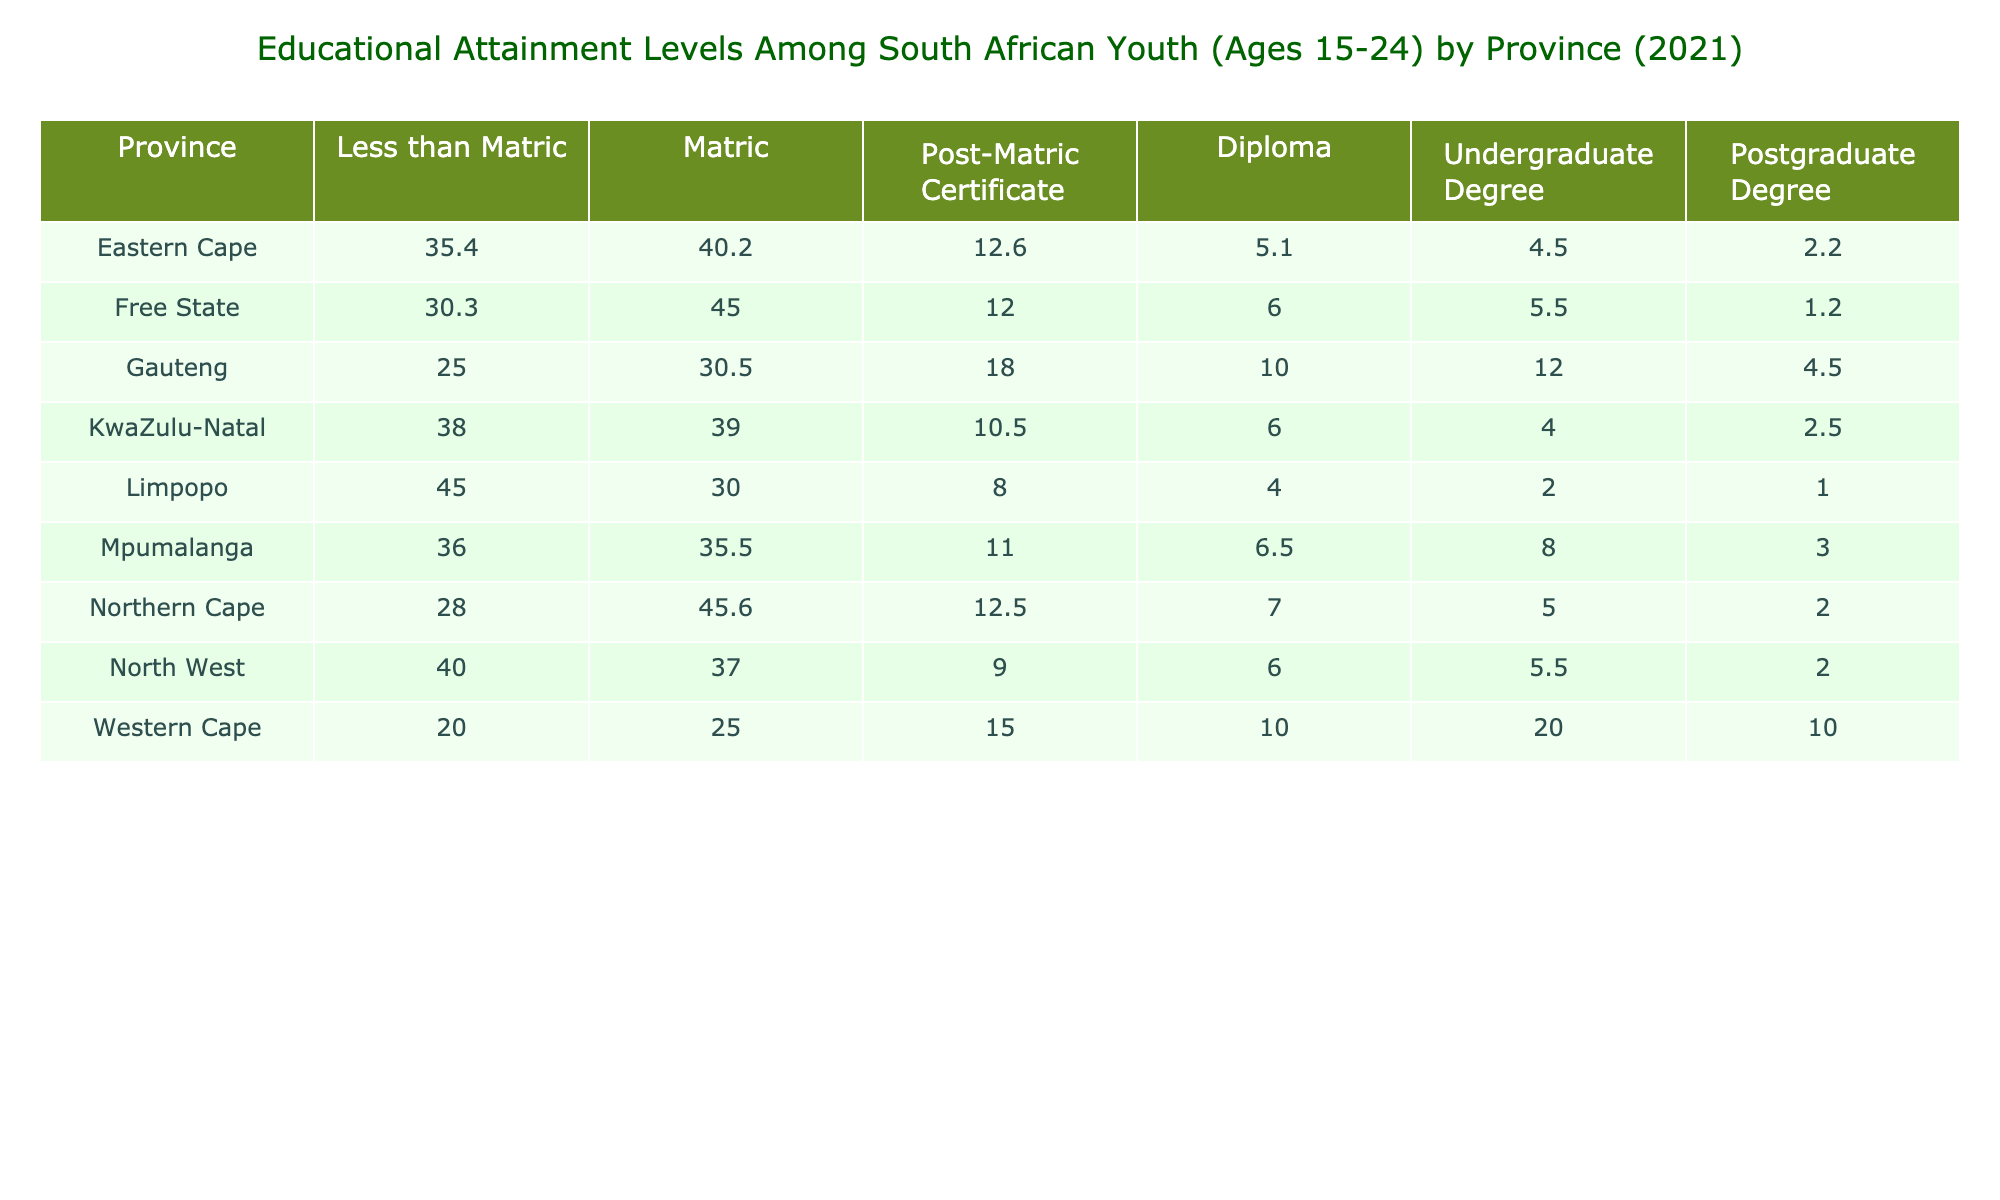What percentage of youth in the Eastern Cape have a postgraduate degree? According to the table, in the Eastern Cape, the percentage of youth with a postgraduate degree is 2.2%.
Answer: 2.2% Which province has the highest percentage of youth with less than Matric? Based on the table, Limpopo has the highest percentage of youth with less than Matric at 45.0%.
Answer: Limpopo What is the total percentage of youth in Gauteng with Matric and Post-Matric Certificate combined? In Gauteng, the percentage with Matric is 30.5% and with a Post-Matric Certificate is 18.0%. To find the total, we add these two values: 30.5 + 18.0 = 48.5%.
Answer: 48.5% Is it true that more youth in the Western Cape have an undergraduate degree than in the Free State? In the Western Cape, 20.0% of youth have an undergraduate degree, while in the Free State, it is 5.5%. Therefore, it is true that more youth in the Western Cape have an undergraduate degree.
Answer: Yes What province has the lowest percentage of youth with a Postgraduate Degree, and what is that percentage? By examining the table, we see that the province with the lowest percentage of youth with a Postgraduate Degree is the Free State at 1.2%.
Answer: Free State, 1.2% Calculate the average percentage of youth with diplomas across all provinces. The percentages of youth with diplomas across the provinces are as follows: Eastern Cape (5.1), Free State (6.0), Gauteng (10.0), KwaZulu-Natal (6.0), Limpopo (4.0), Mpumalanga (6.5), Northern Cape (7.0), North West (6.0), and Western Cape (10.0). Summing these gives: 5.1 + 6.0 + 10.0 + 6.0 + 4.0 + 6.5 + 7.0 + 6.0 + 10.0 = 60.6. To find the average, we divide this sum by 9 (the number of provinces): 60.6 / 9 ≈ 6.73%.
Answer: 6.73% Are there more youth in Mpumalanga with a Matric than in KwaZulu-Natal? In Mpumalanga, the percentage with Matric is 35.5%, while in KwaZulu-Natal it is 39.0%. Therefore, there are fewer youth in Mpumalanga with Matric compared to KwaZulu-Natal.
Answer: No What is the difference in percentage of youth with a Post-Matric Certificate between Gauteng and Limpopo? In Gauteng, the percentage with a Post-Matric Certificate is 18.0%, and in Limpopo, it is 8.0%. The difference is calculated as 18.0 - 8.0 = 10.0%.
Answer: 10.0% 